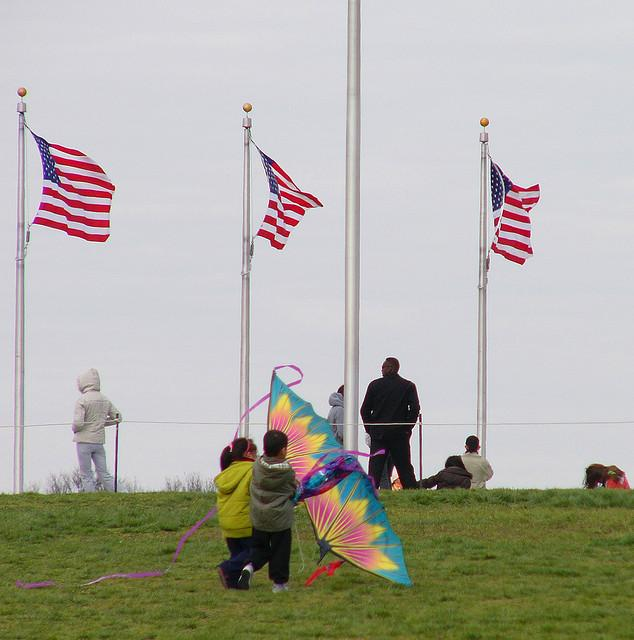What are the silver poles being used for? Please explain your reasoning. flying flags. The silver poles are flag poles. 